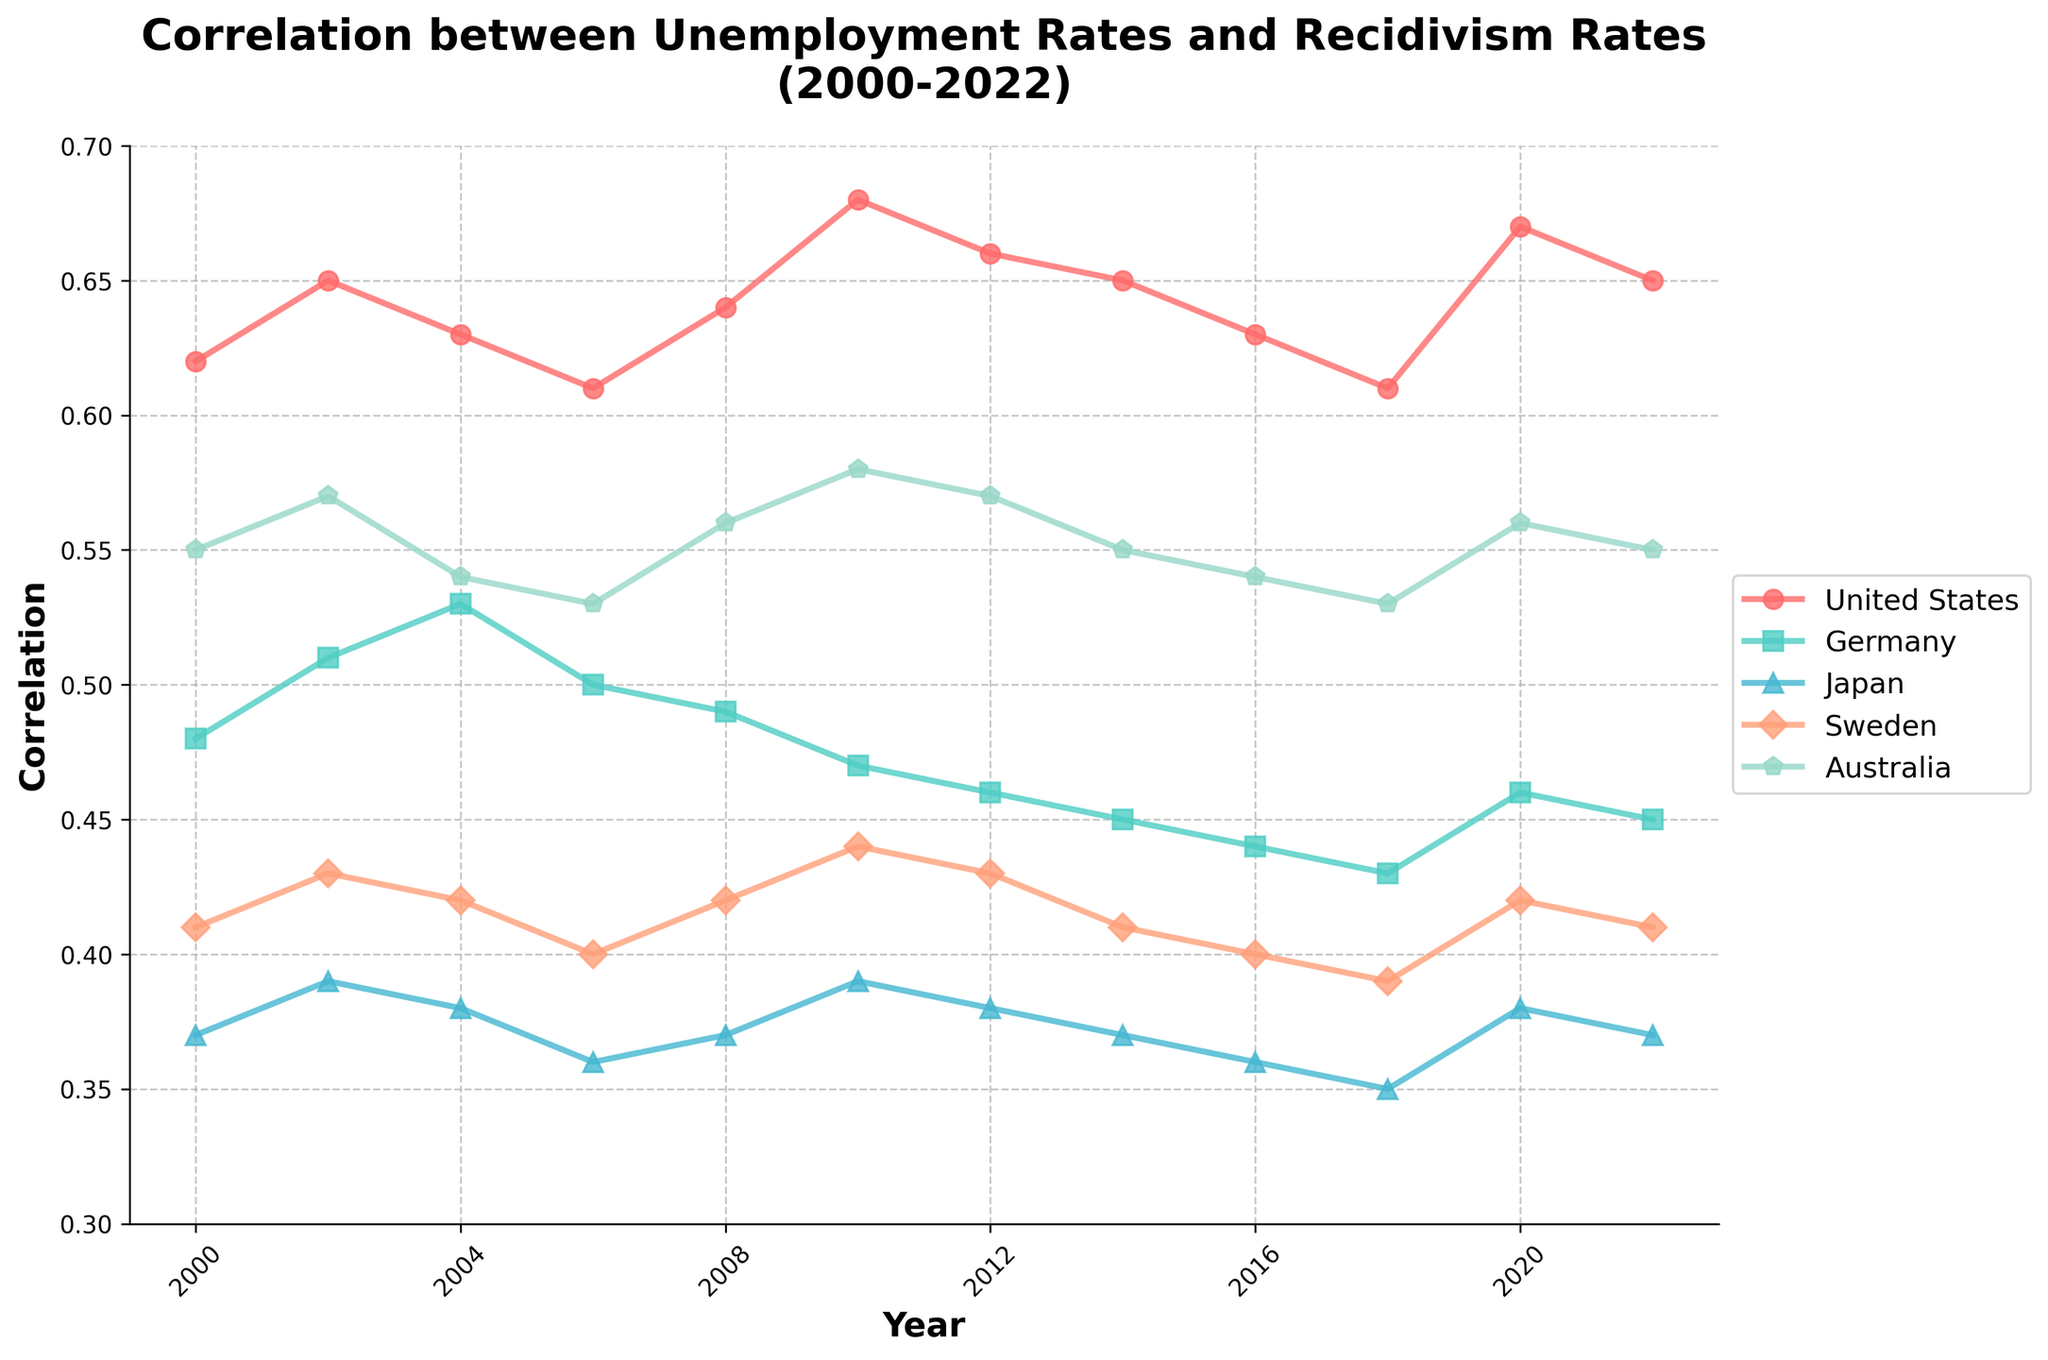What is the general trend of the correlation between unemployment rates and recidivism rates in the United States from 2000 to 2022? To identify the trend, examine the line representing the United States from 2000 to 2022. Starting at 0.62 in 2000, the correlation increases overall, reaching a peak at 0.68 in 2010 before fluctuating slightly and stabilizing around 0.65 in 2022.
Answer: Increasing overall, with some fluctuation Which country had the highest correlation in 2010? Look at the points corresponding to 2010 for all countries. The United States has the highest value at this point, which is 0.68.
Answer: United States What is the average correlation for Germany across the years 2000, 2010, and 2020? Sum the values for Germany in the years 2000, 2010, and 2020 and then divide by 3: (0.48 + 0.47 + 0.46) / 3 = 0.47.
Answer: 0.47 Between which pairs of countries is the correlation most similar in 2022? Compare the ending points for each line in 2022. Germany (0.45) and Sweden (0.41) are very close but the closest pair is Japan (0.37) and Sweden (0.41), which are 0.04 apart.
Answer: Japan and Sweden How did the correlation for Sweden change from 2008 to 2016? Subtract the 2016 value from the 2008 value for Sweden: 0.40 (2016) - 0.42 (2008) = -0.02. The negative result indicates a slight decrease.
Answer: Decreased by 0.02 Which country experienced the greatest fluctuation in correlation from 2000 to 2022? Determine the range (max-min) for each country. The United States varied from 0.61 to 0.68, Germany from 0.43 to 0.53, Japan from 0.35 to 0.39, Sweden from 0.39 to 0.44, and Australia from 0.53 to 0.58. The United States has the greatest fluctuation of 0.07.
Answer: United States In which year did Australia have its lowest correlation value and what was it? Find the lowest point on the line for Australia. The lowest value is 0.53, occurring in both 2016 and 2018.
Answer: 2016 and 2018, 0.53 Compare the overall trends of Japan and Sweden. How are they similar or different? Both lines are relatively close and display minor fluctuations. Japan ranges from 0.35 to 0.39 with a gradual decrease, and Sweden ranges from 0.39 to 0.44, also showing minor fluctuations.
Answer: Both have minor fluctuations; Japan has a gradual decrease, Sweden remains relatively stable What is the median correlation value for all countries combined in 2020? Combine and sort all countries' values for 2020: 0.46 (Germany), 0.38 (Japan), 0.42 (Sweden), 0.67 (United States), 0.56 (Australia). The median is the third value in the sorted list.
Answer: 0.46 (Germany) Which country showed the most consistent correlation over the years? A consistent correlation implies small fluctuations. Japan ranges from 0.35 to 0.39 without significant changes, showing the most consistency.
Answer: Japan 